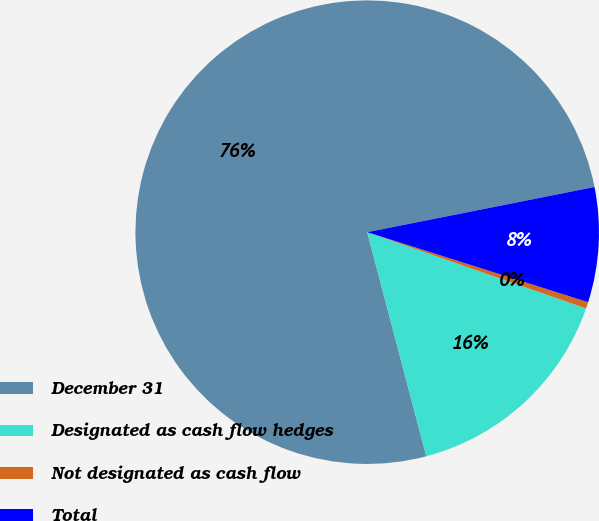Convert chart to OTSL. <chart><loc_0><loc_0><loc_500><loc_500><pie_chart><fcel>December 31<fcel>Designated as cash flow hedges<fcel>Not designated as cash flow<fcel>Total<nl><fcel>75.98%<fcel>15.56%<fcel>0.45%<fcel>8.01%<nl></chart> 